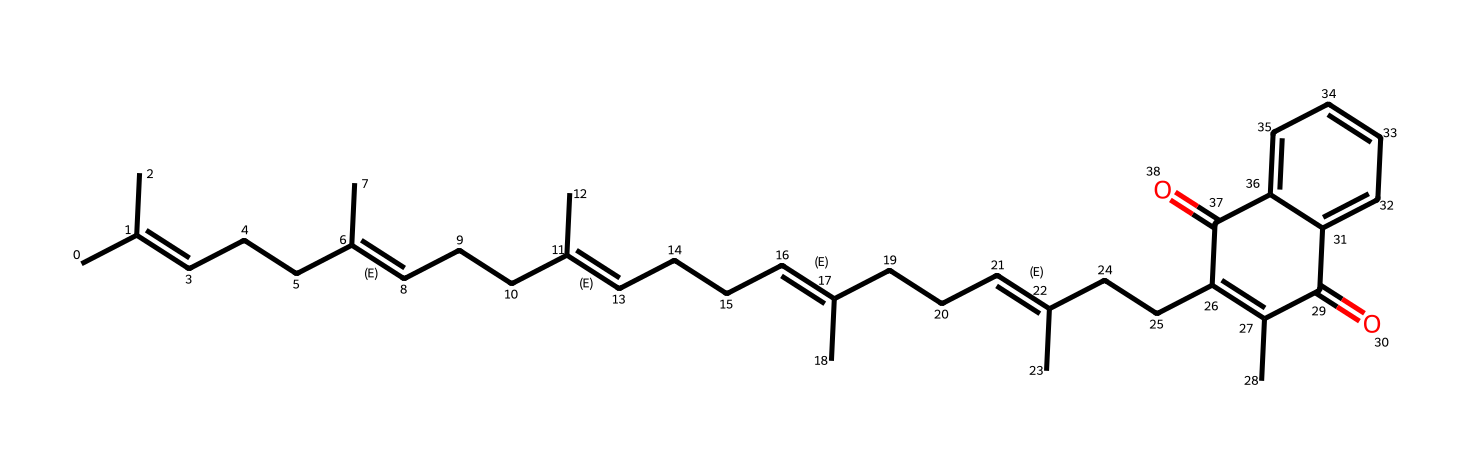What is the primary function of vitamin K2 in the body? Vitamin K2 is primarily known for its role in blood clotting and maintaining heart health, as it helps in the synthesis of proteins required for these processes.
Answer: blood clotting and heart health How many double bonds are present in the structure of vitamin K2? By analyzing the SMILES representation, we can identify double bonds, which are shown as "=" in the structure. Counting these reveals there are five double bonds in vitamin K2.
Answer: five What type of vitamin is K2 classified as? Vitamin K2 is classified as a fat-soluble vitamin, which is indicated by its general structure that includes long hydrocarbon chains.
Answer: fat-soluble What is the molecular weight of vitamin K2 based on its structure? To determine the molecular weight, we would count all the atoms in the SMILES and use their respective atomic weights. The resulting molecular weight of vitamin K2 is approximately 450 grams per mole.
Answer: 450 grams per mole Which chemical functional groups are present in vitamin K2? In the structure of vitamin K2, we observe the presence of carbonyl groups (C=O) and a series of aliphatic hydrocarbon chains, which indicate that it has specific functional characteristics.
Answer: carbonyl groups and aliphatic hydrocarbons What is the total number of carbon atoms in vitamin K2? By systematically counting the carbon atoms present in the provided SMILES representation, we can determine that there are 30 carbon atoms in total.
Answer: 30 